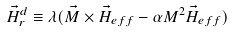<formula> <loc_0><loc_0><loc_500><loc_500>\vec { H } _ { r } ^ { d } \equiv \lambda ( \vec { M } \times \vec { H } _ { e f f } - { \alpha } M ^ { 2 } \vec { H } _ { e f f } )</formula> 